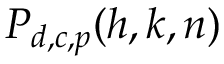Convert formula to latex. <formula><loc_0><loc_0><loc_500><loc_500>P _ { d , c , p } ( h , k , n )</formula> 